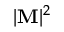<formula> <loc_0><loc_0><loc_500><loc_500>| M | ^ { 2 }</formula> 